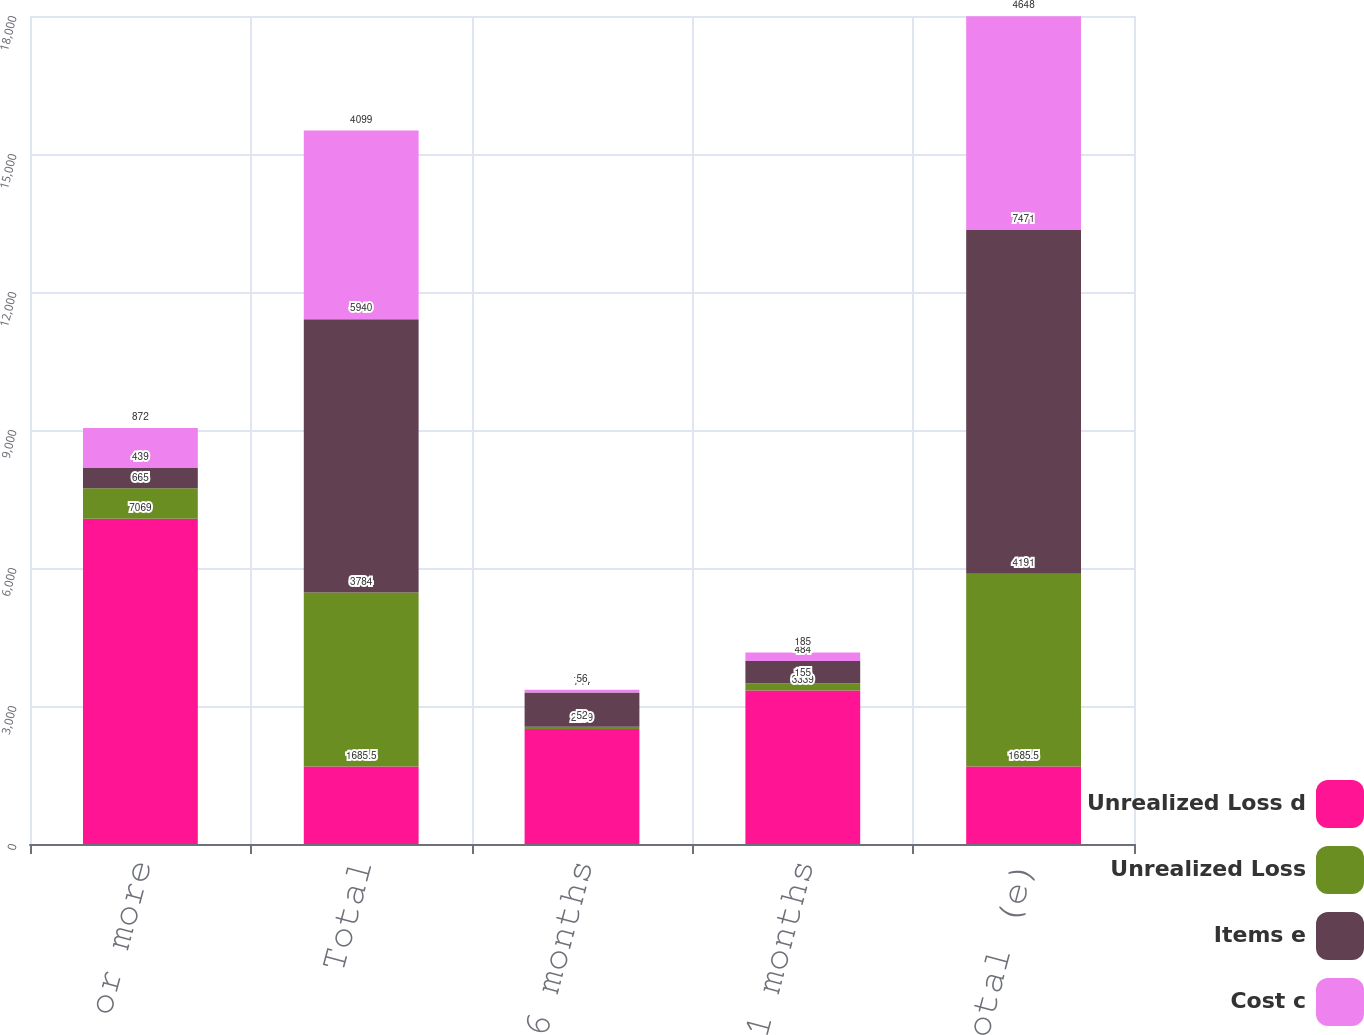Convert chart. <chart><loc_0><loc_0><loc_500><loc_500><stacked_bar_chart><ecel><fcel>12 months or more<fcel>Total<fcel>0 - 6 months<fcel>7 - 11 months<fcel>Total (e)<nl><fcel>Unrealized Loss d<fcel>7069<fcel>1685.5<fcel>2499<fcel>3339<fcel>1685.5<nl><fcel>Unrealized Loss<fcel>665<fcel>3784<fcel>52<fcel>155<fcel>4191<nl><fcel>Items e<fcel>439<fcel>5940<fcel>744<fcel>484<fcel>7471<nl><fcel>Cost c<fcel>872<fcel>4099<fcel>56<fcel>185<fcel>4648<nl></chart> 